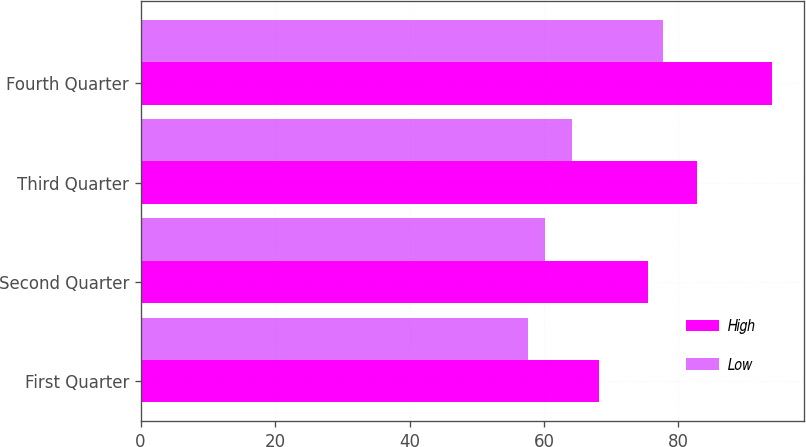<chart> <loc_0><loc_0><loc_500><loc_500><stacked_bar_chart><ecel><fcel>First Quarter<fcel>Second Quarter<fcel>Third Quarter<fcel>Fourth Quarter<nl><fcel>High<fcel>68.16<fcel>75.44<fcel>82.76<fcel>93.95<nl><fcel>Low<fcel>57.62<fcel>60.21<fcel>64.22<fcel>77.67<nl></chart> 